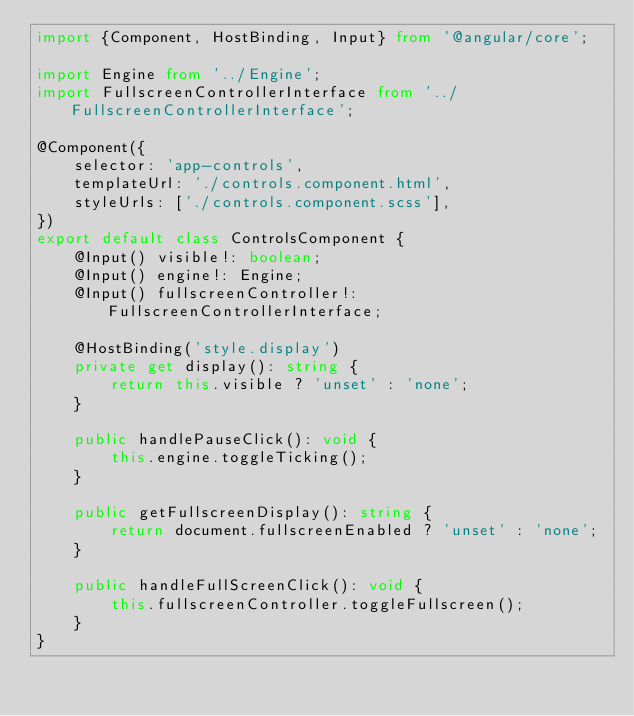Convert code to text. <code><loc_0><loc_0><loc_500><loc_500><_TypeScript_>import {Component, HostBinding, Input} from '@angular/core';

import Engine from '../Engine';
import FullscreenControllerInterface from '../FullscreenControllerInterface';

@Component({
    selector: 'app-controls',
    templateUrl: './controls.component.html',
    styleUrls: ['./controls.component.scss'],
})
export default class ControlsComponent {
    @Input() visible!: boolean;
    @Input() engine!: Engine;
    @Input() fullscreenController!: FullscreenControllerInterface;

    @HostBinding('style.display')
    private get display(): string {
        return this.visible ? 'unset' : 'none';
    }

    public handlePauseClick(): void {
        this.engine.toggleTicking();
    }

    public getFullscreenDisplay(): string {
        return document.fullscreenEnabled ? 'unset' : 'none';
    }

    public handleFullScreenClick(): void {
        this.fullscreenController.toggleFullscreen();
    }
}
</code> 